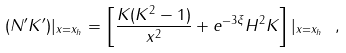Convert formula to latex. <formula><loc_0><loc_0><loc_500><loc_500>( N ^ { \prime } K ^ { \prime } ) | _ { x = x _ { h } } = \left [ \frac { K ( K ^ { 2 } - 1 ) } { x ^ { 2 } } + e ^ { - 3 \xi } H ^ { 2 } K \right ] | _ { x = x _ { h } } \ ,</formula> 